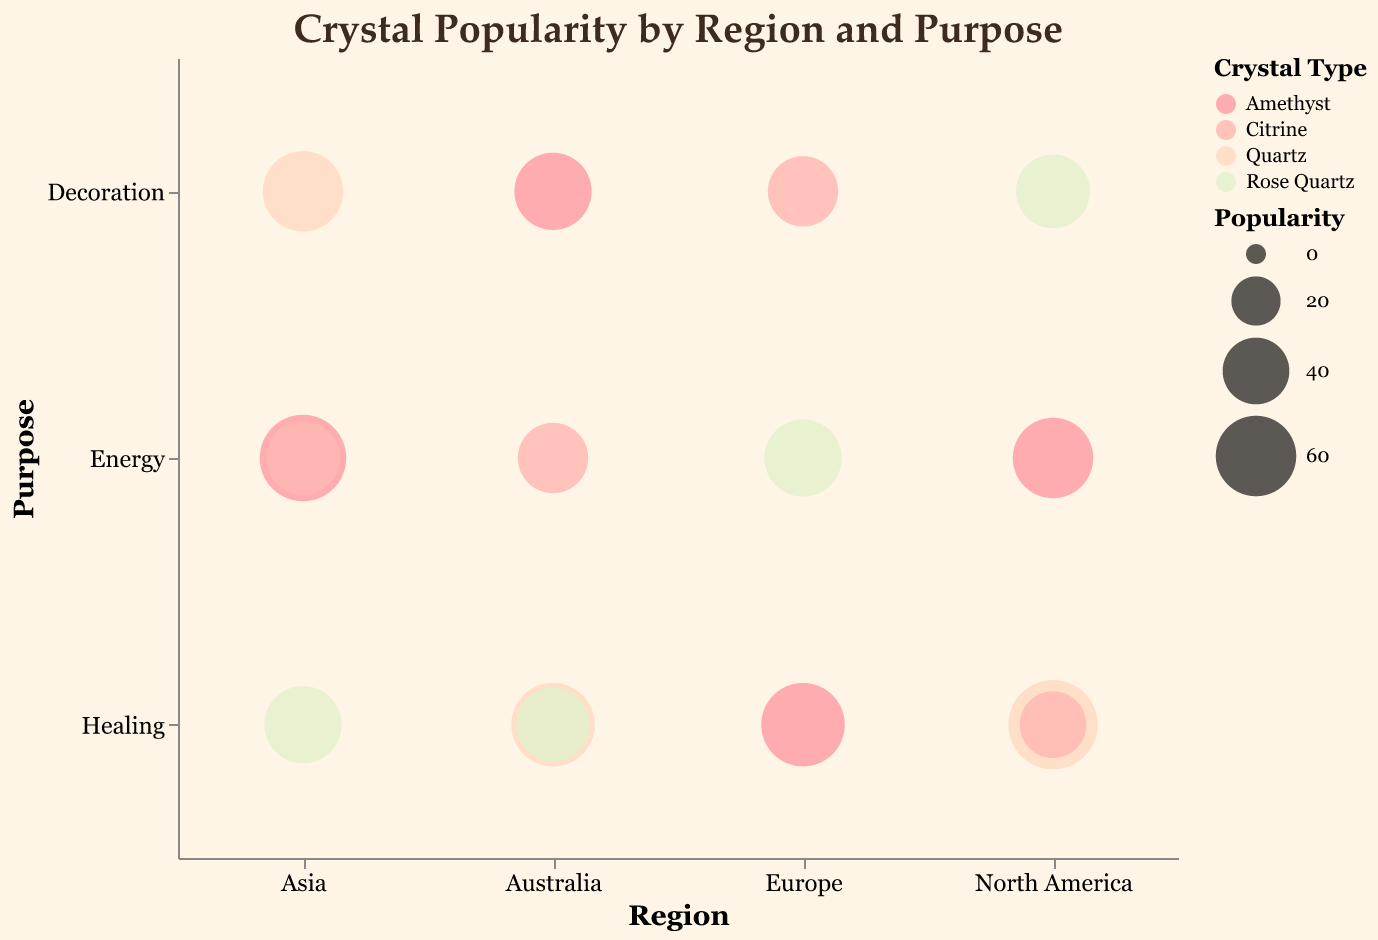What is the title of the figure? The figure's title is written at the top and it is about crystal popularity by region and purpose.
Answer: Crystal Popularity by Region and Purpose How many regions are represented in the chart? The x-axis represents regions, and there are North America, Europe, Asia, and Australia.
Answer: 4 Which crystal type is most popular for energy in Europe? In Europe, the bubble largest in size for energy is associated with Rose Quartz in the color scheme.
Answer: Rose Quartz What is the least popular crystal type for healing in Australia? On the y-axis under healing in Australia, the smallest bubble represents Rose Quartz for healing.
Answer: Rose Quartz Which crystal type has the highest popularity score in North America and for what purpose? In North America, the largest bubble has the highest popularity score, which is Quartz for healing.
Answer: Quartz for Healing Which crystal type is commonly used for energy purposes in North America, and how is its popularity compared to the same purpose in another region? In North America, Amethyst is used for energy with a popularity score of 60, while in Asia it has a higher score of 70 for energy.
Answer: Amethyst (higher popularity in Asia) What is the combined popularity of quartz in Asia for healing and decoration purposes? Quartz popularity for healing in Asia is 65 and for decoration is 60. Sum these values: 65 + 60 = 125.
Answer: 125 Compare the popularity of amethyst for energy between North America and Asia. The popularity of amethyst for energy in North America is 60, whereas in Asia, it is 70. Comparing these, Asia has a higher popularity.
Answer: Asia has higher popularity Which crystal is used for decoration in Australia and what is its popularity score? In Australia, the bubble representing the decoration purpose is associated with amethyst with a popularity score of 55.
Answer: Amethyst with 55 How does the popularity of Citrine for healing in North America compare with its popularity for decoration in Europe? Citrine for healing in North America has a popularity score of 40 and for decoration in Europe has 45. Comparing these, Europe has a slightly higher popularity score.
Answer: Europe has higher popularity 